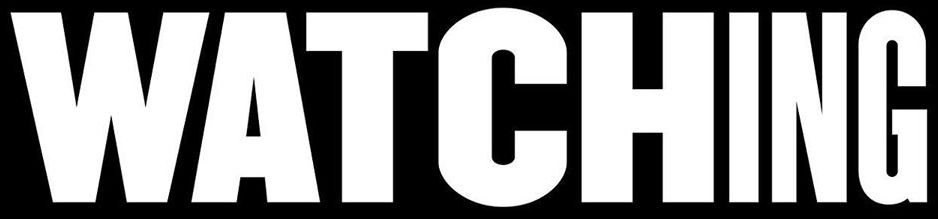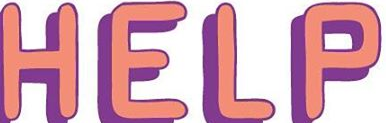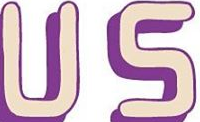What words can you see in these images in sequence, separated by a semicolon? WATCHING; HELP; US 